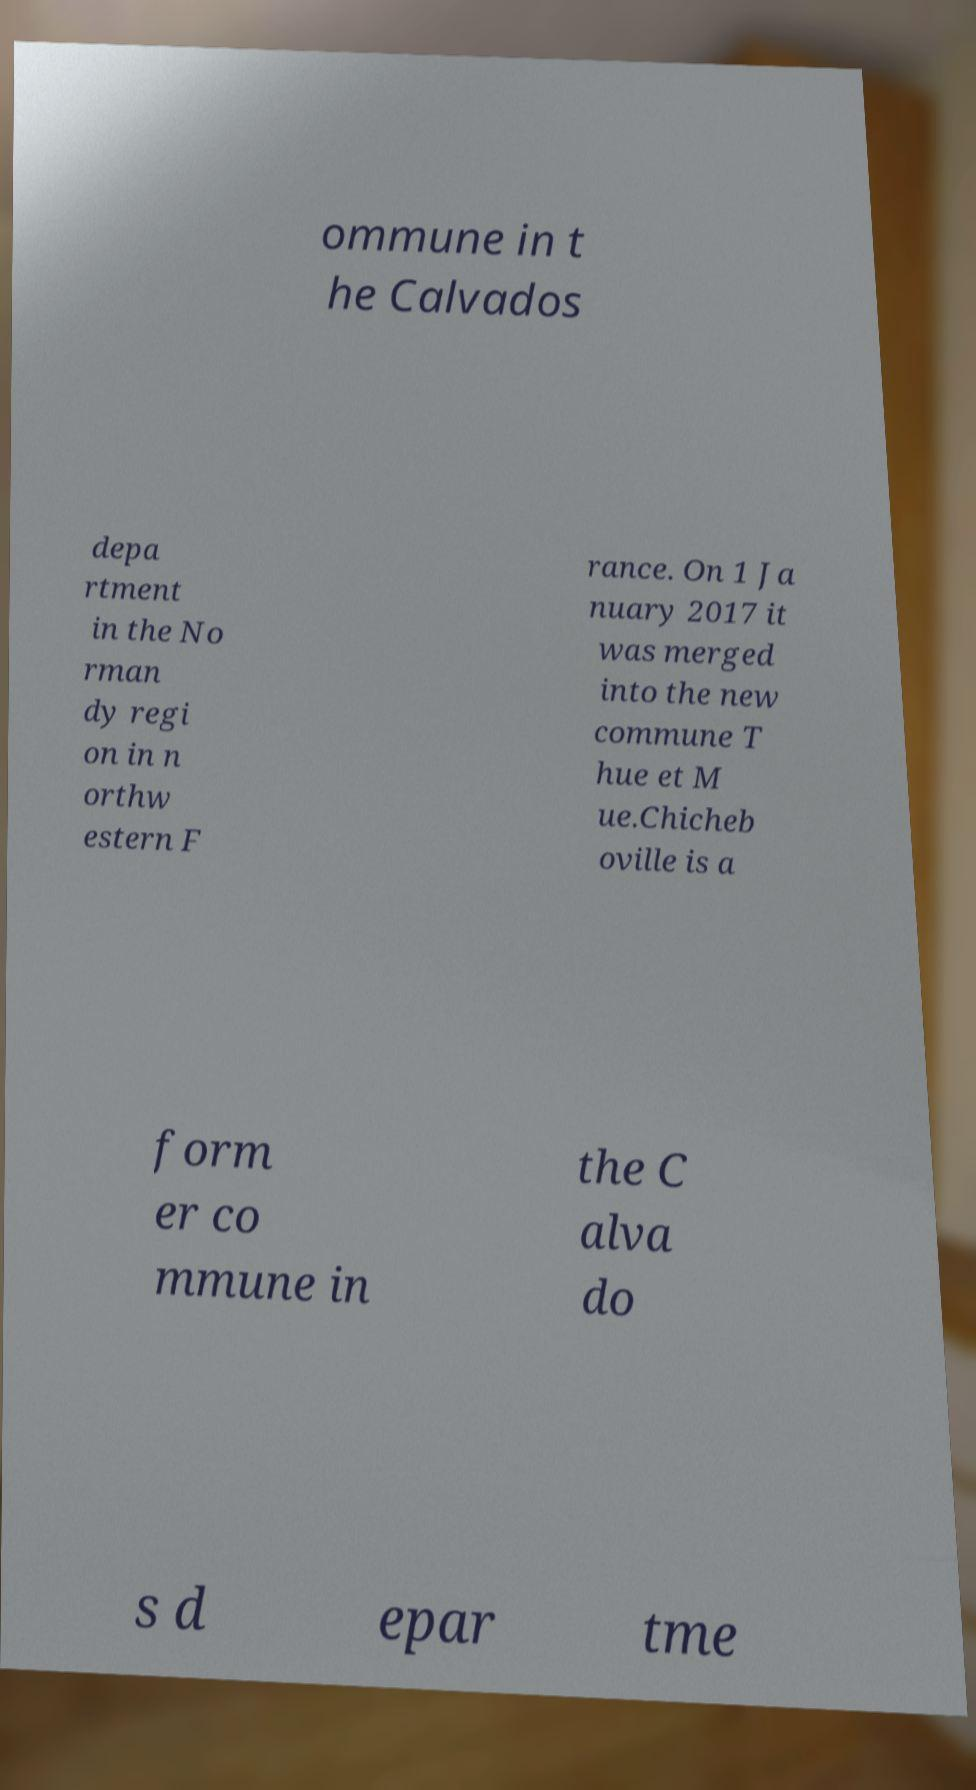Please read and relay the text visible in this image. What does it say? ommune in t he Calvados depa rtment in the No rman dy regi on in n orthw estern F rance. On 1 Ja nuary 2017 it was merged into the new commune T hue et M ue.Chicheb oville is a form er co mmune in the C alva do s d epar tme 